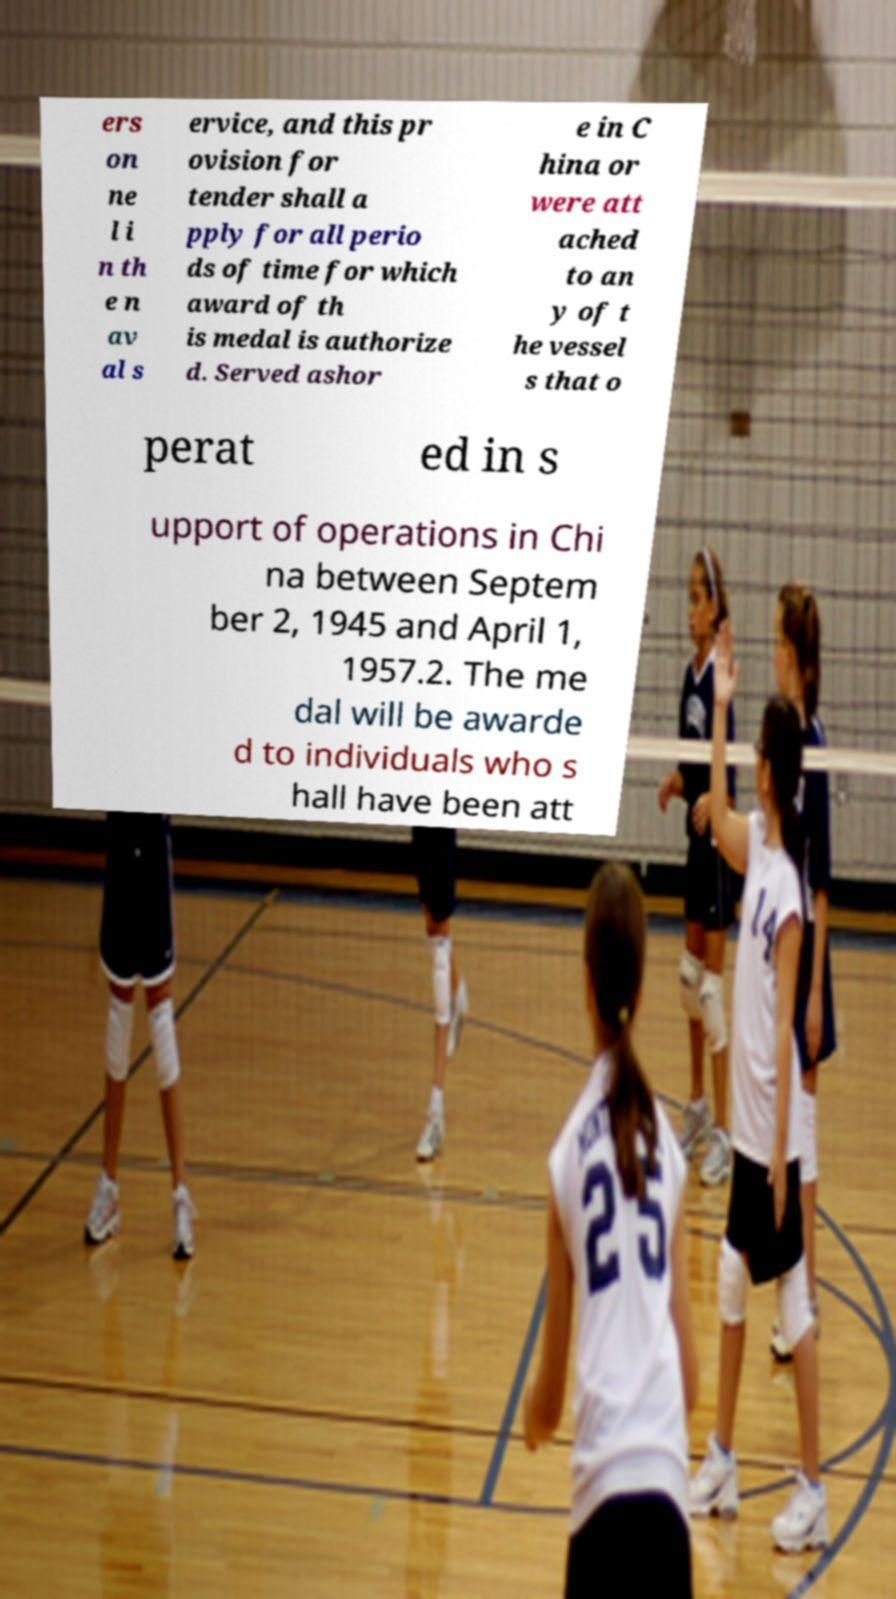I need the written content from this picture converted into text. Can you do that? ers on ne l i n th e n av al s ervice, and this pr ovision for tender shall a pply for all perio ds of time for which award of th is medal is authorize d. Served ashor e in C hina or were att ached to an y of t he vessel s that o perat ed in s upport of operations in Chi na between Septem ber 2, 1945 and April 1, 1957.2. The me dal will be awarde d to individuals who s hall have been att 